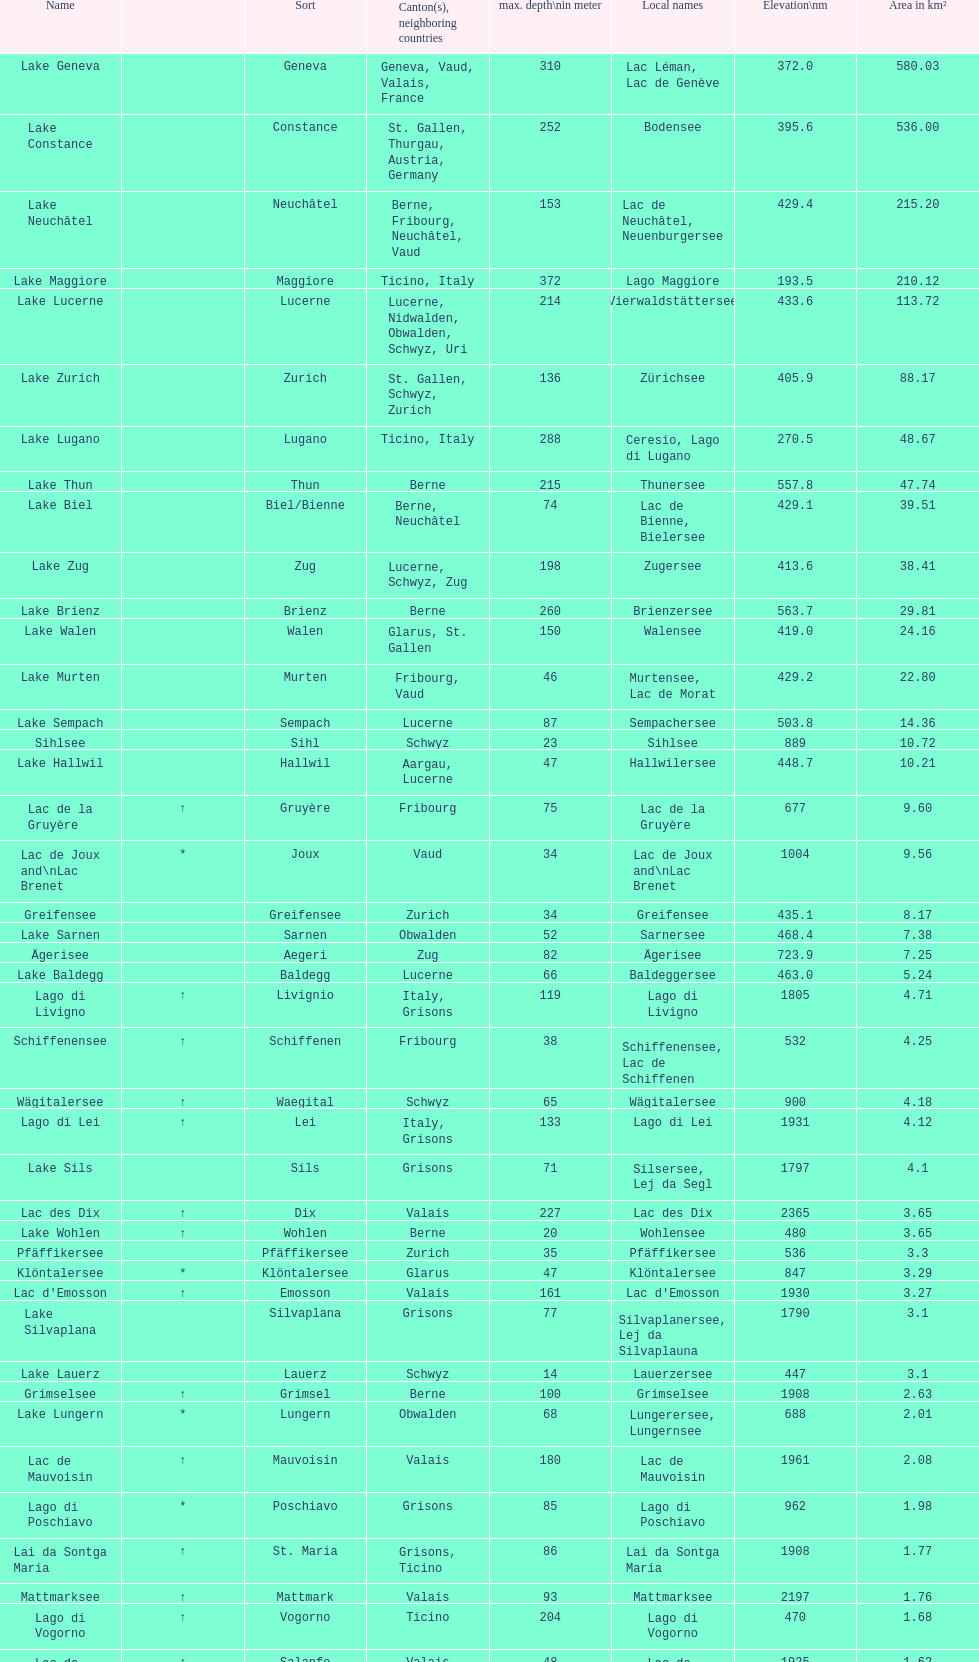What's the total max depth of lake geneva and lake constance combined? 562. 